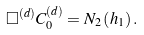Convert formula to latex. <formula><loc_0><loc_0><loc_500><loc_500>\Box ^ { ( d ) } C _ { 0 } ^ { ( d ) } = N _ { 2 } \left ( h _ { 1 } \right ) .</formula> 